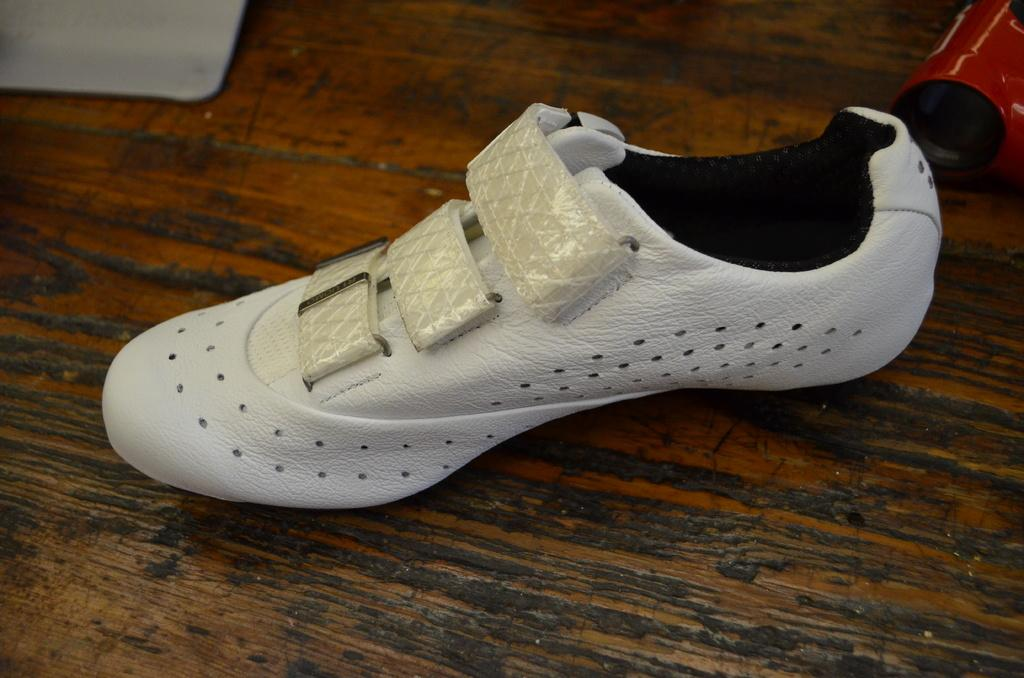What is the main subject in the foreground of the image? There is a shoe in the foreground of the image. What type of surface is the shoe placed on? The shoe is on a wooden surface. Can you describe the objects at the top of the image? Unfortunately, the provided facts do not give any information about the objects at the top of the image. What type of bone can be seen sticking out of the shoe in the image? There is no bone present in the image; it features a shoe on a wooden surface. Are there any flowers visible in the image? The provided facts do not mention any flowers in the image. 